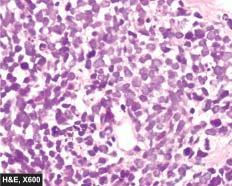re some leucocytes and red cells and a tight meshwork small, uniform, lymphocyte-like with scanty cytoplasm?
Answer the question using a single word or phrase. No 